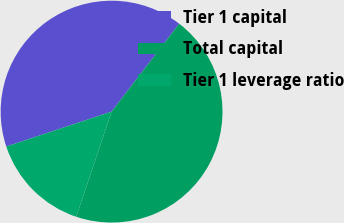<chart> <loc_0><loc_0><loc_500><loc_500><pie_chart><fcel>Tier 1 capital<fcel>Total capital<fcel>Tier 1 leverage ratio<nl><fcel>40.52%<fcel>44.73%<fcel>14.75%<nl></chart> 